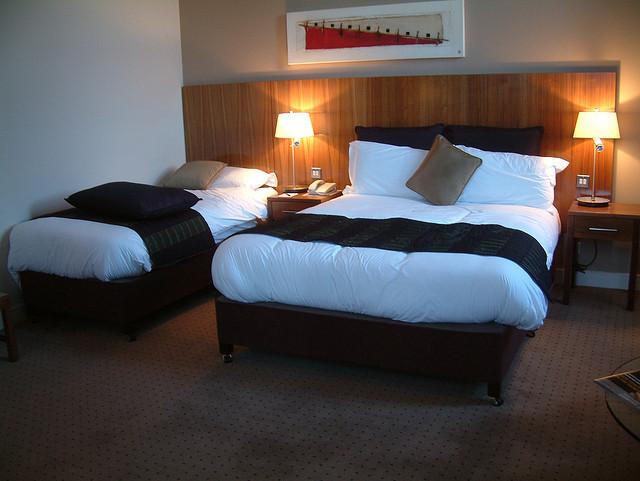How many lamps are there?
Give a very brief answer. 2. Are these beds made?
Quick response, please. Yes. Are both beds the same size?
Concise answer only. No. 